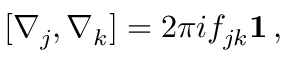<formula> <loc_0><loc_0><loc_500><loc_500>[ \nabla _ { j } , \nabla _ { k } ] = 2 \pi i f _ { j k } { 1 } \, ,</formula> 